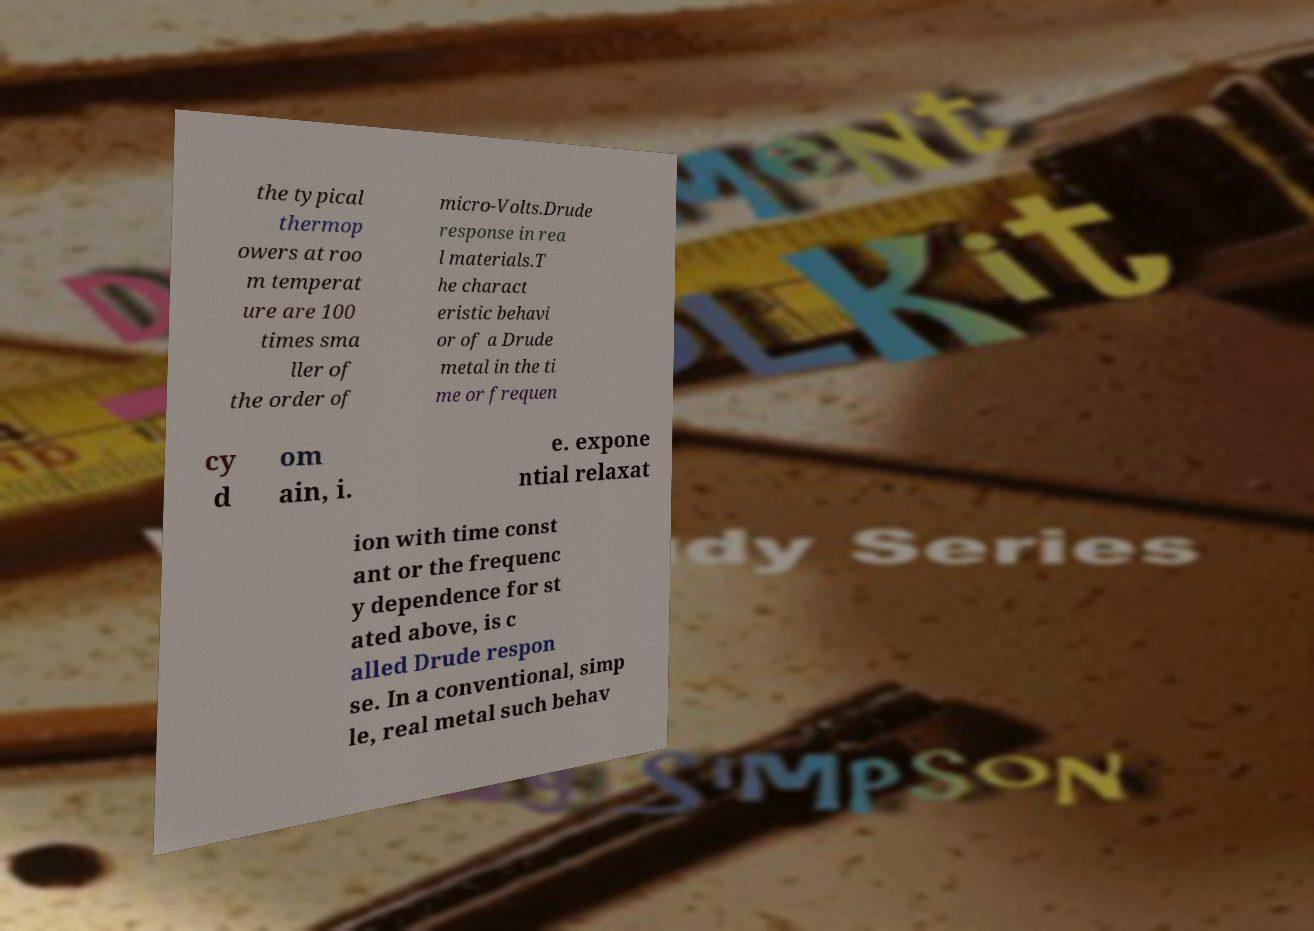Please identify and transcribe the text found in this image. the typical thermop owers at roo m temperat ure are 100 times sma ller of the order of micro-Volts.Drude response in rea l materials.T he charact eristic behavi or of a Drude metal in the ti me or frequen cy d om ain, i. e. expone ntial relaxat ion with time const ant or the frequenc y dependence for st ated above, is c alled Drude respon se. In a conventional, simp le, real metal such behav 